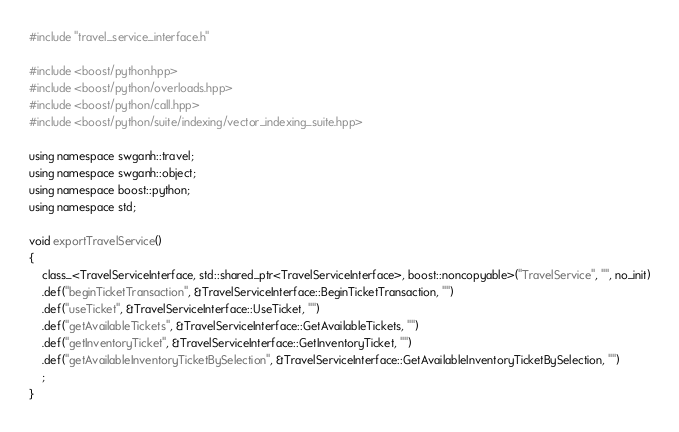Convert code to text. <code><loc_0><loc_0><loc_500><loc_500><_C_>#include "travel_service_interface.h"

#include <boost/python.hpp>
#include <boost/python/overloads.hpp>
#include <boost/python/call.hpp>
#include <boost/python/suite/indexing/vector_indexing_suite.hpp>

using namespace swganh::travel;
using namespace swganh::object;
using namespace boost::python;
using namespace std;

void exportTravelService()
{
    class_<TravelServiceInterface, std::shared_ptr<TravelServiceInterface>, boost::noncopyable>("TravelService", "", no_init)
    .def("beginTicketTransaction", &TravelServiceInterface::BeginTicketTransaction, "")
    .def("useTicket", &TravelServiceInterface::UseTicket, "")
    .def("getAvailableTickets", &TravelServiceInterface::GetAvailableTickets, "")
    .def("getInventoryTicket", &TravelServiceInterface::GetInventoryTicket, "")
    .def("getAvailableInventoryTicketBySelection", &TravelServiceInterface::GetAvailableInventoryTicketBySelection, "")
    ;
}
</code> 